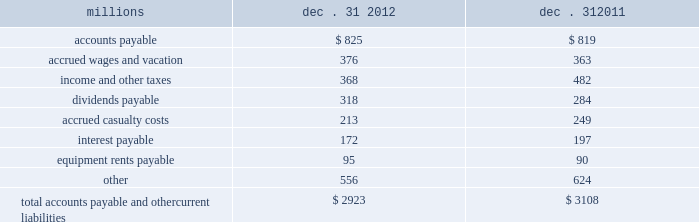The analysis of our depreciation studies .
Changes in the estimated service lives of our assets and their related depreciation rates are implemented prospectively .
Under group depreciation , the historical cost ( net of salvage ) of depreciable property that is retired or replaced in the ordinary course of business is charged to accumulated depreciation and no gain or loss is recognized .
The historical cost of certain track assets is estimated using ( i ) inflation indices published by the bureau of labor statistics and ( ii ) the estimated useful lives of the assets as determined by our depreciation studies .
The indices were selected because they closely correlate with the major costs of the properties comprising the applicable track asset classes .
Because of the number of estimates inherent in the depreciation and retirement processes and because it is impossible to precisely estimate each of these variables until a group of property is completely retired , we continually monitor the estimated service lives of our assets and the accumulated depreciation associated with each asset class to ensure our depreciation rates are appropriate .
In addition , we determine if the recorded amount of accumulated depreciation is deficient ( or in excess ) of the amount indicated by our depreciation studies .
Any deficiency ( or excess ) is amortized as a component of depreciation expense over the remaining service lives of the applicable classes of assets .
For retirements of depreciable railroad properties that do not occur in the normal course of business , a gain or loss may be recognized if the retirement meets each of the following three conditions : ( i ) is unusual , ( ii ) is material in amount , and ( iii ) varies significantly from the retirement profile identified through our depreciation studies .
A gain or loss is recognized in other income when we sell land or dispose of assets that are not part of our railroad operations .
When we purchase an asset , we capitalize all costs necessary to make the asset ready for its intended use .
However , many of our assets are self-constructed .
A large portion of our capital expenditures is for replacement of existing track assets and other road properties , which is typically performed by our employees , and for track line expansion and other capacity projects .
Costs that are directly attributable to capital projects ( including overhead costs ) are capitalized .
Direct costs that are capitalized as part of self- constructed assets include material , labor , and work equipment .
Indirect costs are capitalized if they clearly relate to the construction of the asset .
General and administrative expenditures are expensed as incurred .
Normal repairs and maintenance , including rail grinding , are also expensed as incurred , while costs incurred that extend the useful life of an asset , improve the safety of our operations or improve operating efficiency are capitalized .
These costs are allocated using appropriate statistical bases .
Total expense for repairs and maintenance incurred was $ 2.1 billion for 2012 , $ 2.2 billion for 2011 , and $ 2.0 billion for 2010 .
Assets held under capital leases are recorded at the lower of the net present value of the minimum lease payments or the fair value of the leased asset at the inception of the lease .
Amortization expense is computed using the straight-line method over the shorter of the estimated useful lives of the assets or the period of the related lease .
12 .
Accounts payable and other current liabilities dec .
31 , dec .
31 , millions 2012 2011 .

What was the percentage change in equipment rents payable from 2011 to 2012? 
Computations: ((95 - 90) / 90)
Answer: 0.05556. 